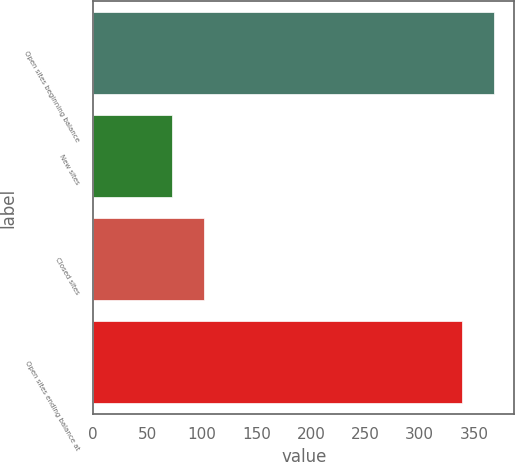Convert chart. <chart><loc_0><loc_0><loc_500><loc_500><bar_chart><fcel>Open sites beginning balance<fcel>New sites<fcel>Closed sites<fcel>Open sites ending balance at<nl><fcel>368.5<fcel>72<fcel>101.5<fcel>339<nl></chart> 